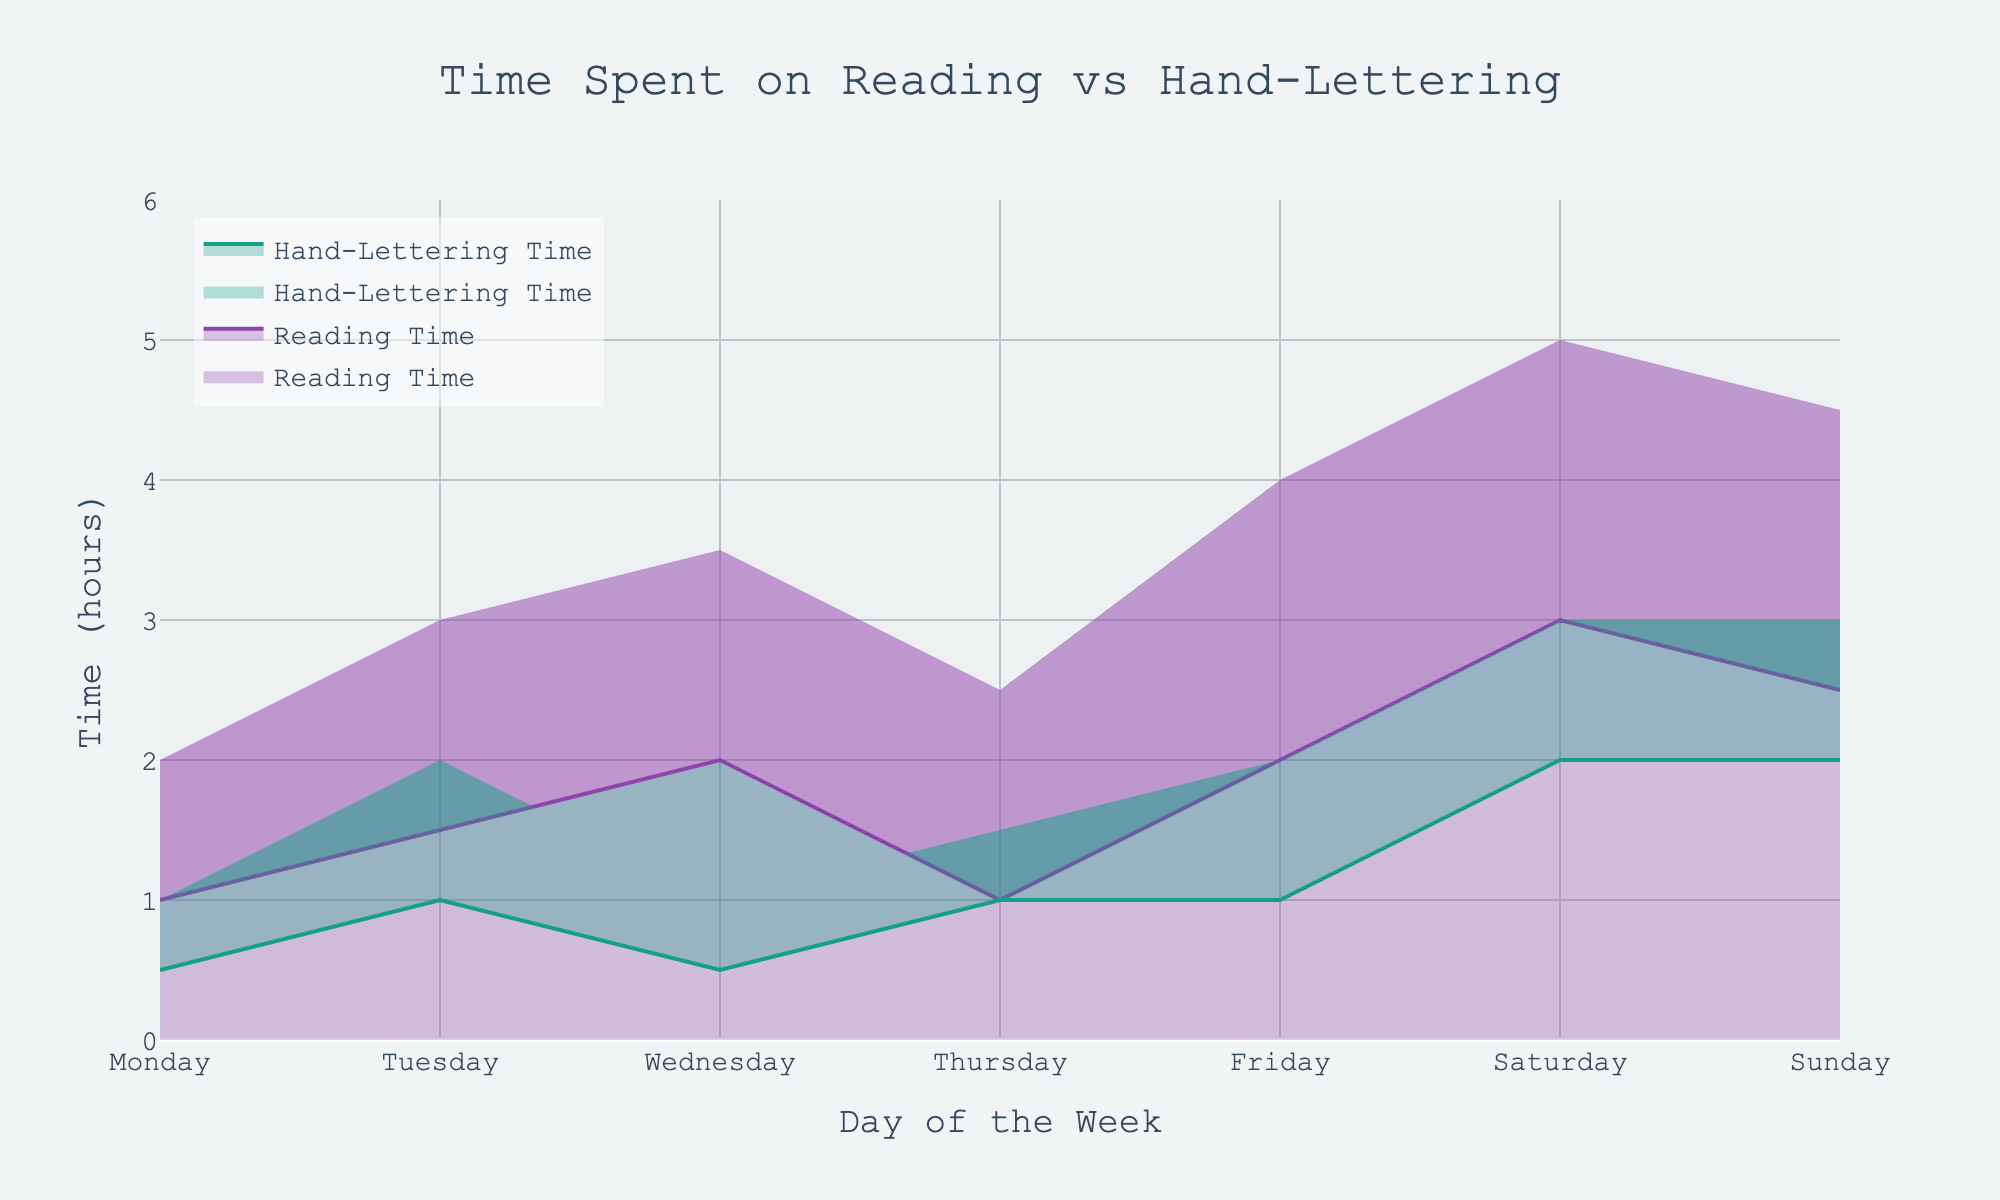What is the title of the figure? The title of the figure is usually displayed at the top of the chart. In this case, it states 'Time Spent on Reading vs Hand-Lettering'.
Answer: Time Spent on Reading vs Hand-Lettering What days have the maximum upper time spent on reading? By observing the upper boundaries of the shaded reading time ranges, Saturdays show the highest value at 5 hours.
Answer: Saturday What is the color used to represent hand-lettering time? The color attributed to hand-lettering time is a shade of green as seen in the chart.
Answer: Green What is the range of time spent reading on Fridays? On Fridays, the lower bound for reading is 2 hours, and the upper bound is 4 hours, giving a range of 2 hours.
Answer: 2-4 hours Which day has the lowest minimum time for hand-lettering? By checking the chart, the day with the lowest lower bound for hand-lettering time is Monday, at 0.5 hours.
Answer: Monday Is there any day where the upper time for reading is less than the lower time for hand-lettering? By evaluating all the days, none of them have an upper reading time that is less than the lower hand-lettering time.
Answer: No On which day is the difference between the maximum upper time for reading and hand-lettering the greatest? To determine this, we look at the maximum upper readings and hand-lettering times across all days. On Saturdays, the upper reading time is 5 hours and the upper hand-lettering time is 3 hours, giving a difference of 2 hours.
Answer: Saturday What is the average upper limit of hand-lettering time across the week? Summing up the upper hand-lettering times (1 + 2 + 1 + 1.5 + 2 + 3 + 3 = 13.5) and dividing by 7 days: 13.5 / 7 = 1.93 (rounded to 2 decimal places).
Answer: 1.93 hours Which day shows the smallest variability in reading time? Variability can be assessed by the range of hours (upper limit - lower limit). Thursday has a lower limit of 1 hour and an upper limit of 2.5 hours, thus 1.5 hours difference which seems to be the smallest range.
Answer: Thursday 